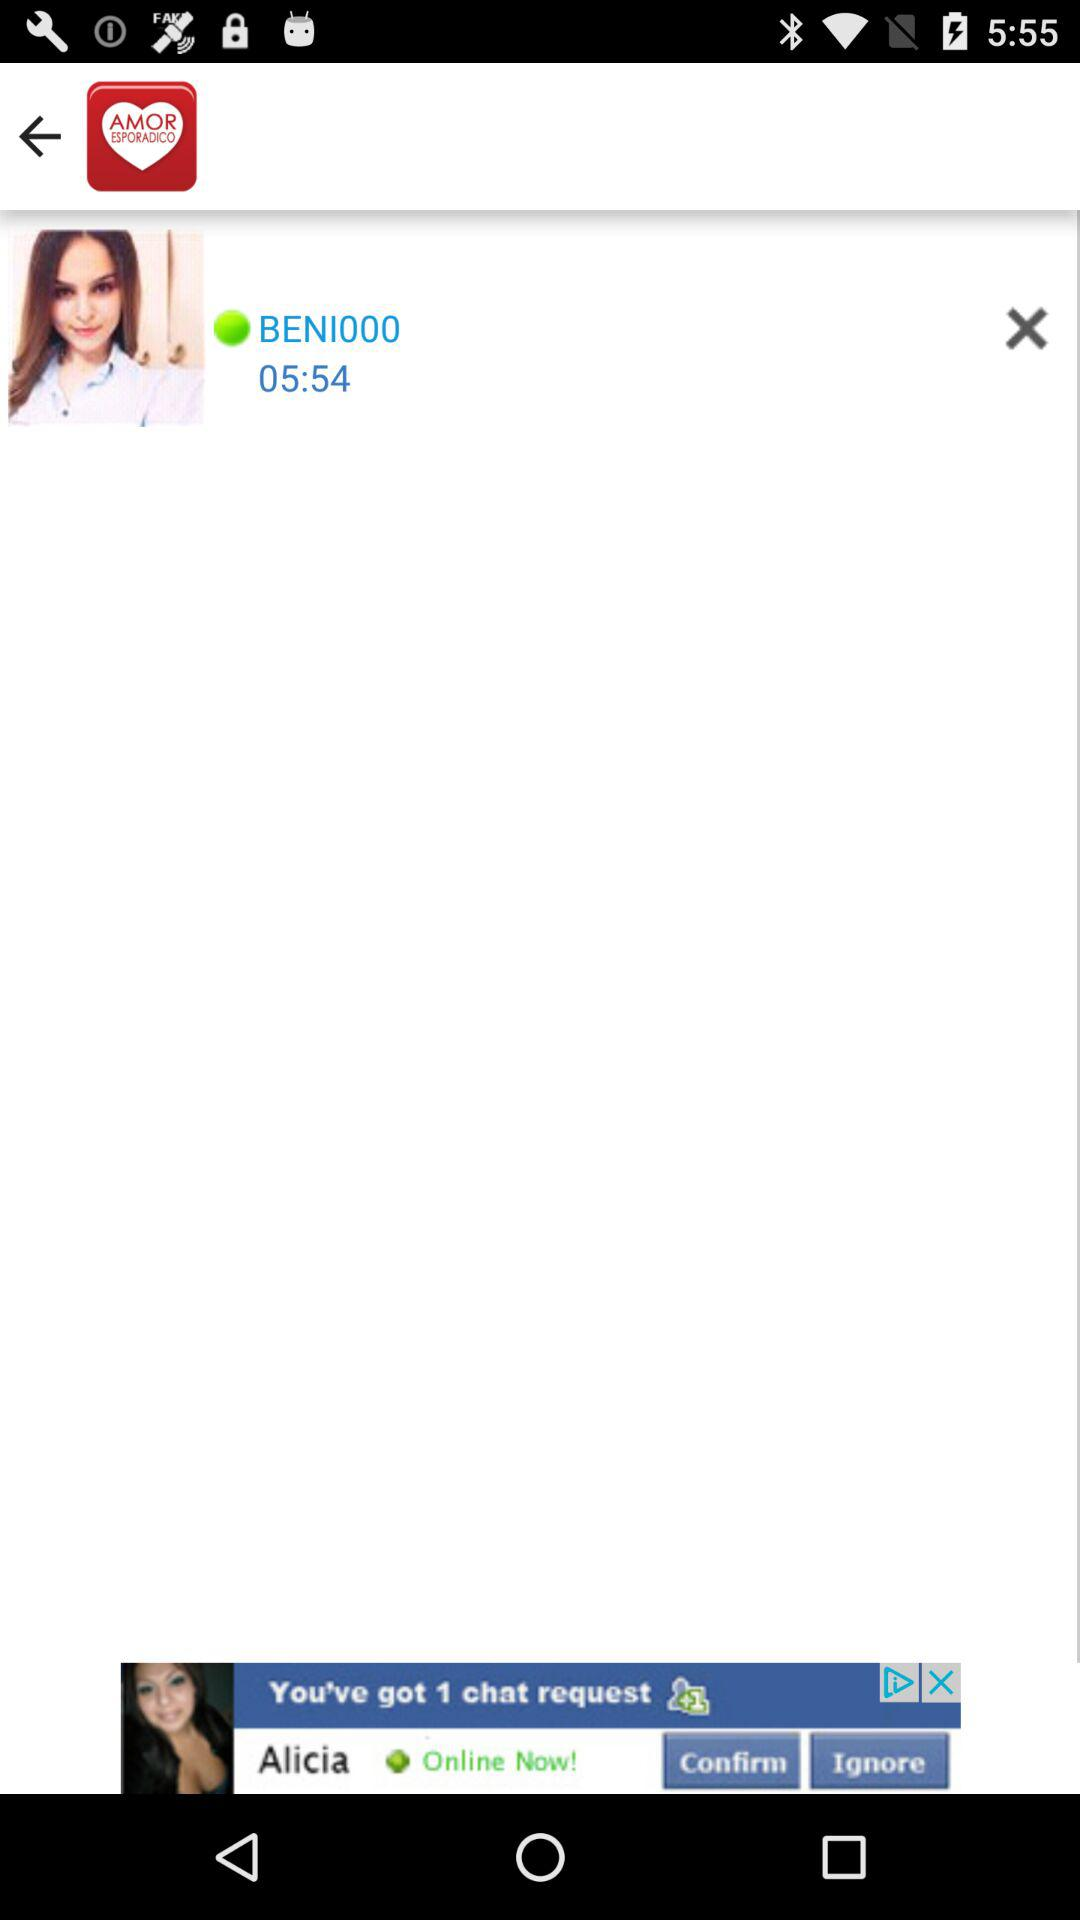Which version of the application is this?
When the provided information is insufficient, respond with <no answer>. <no answer> 